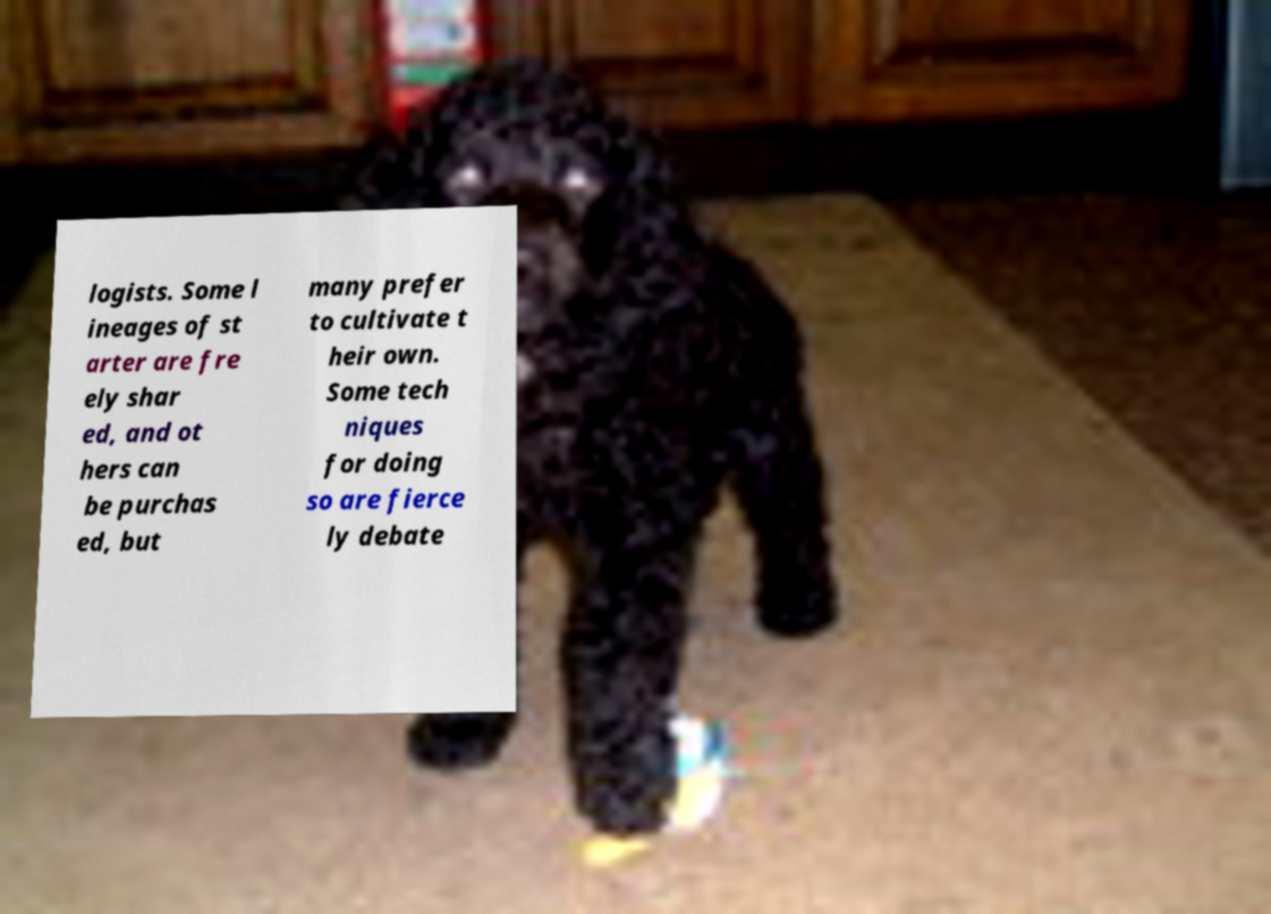Can you accurately transcribe the text from the provided image for me? logists. Some l ineages of st arter are fre ely shar ed, and ot hers can be purchas ed, but many prefer to cultivate t heir own. Some tech niques for doing so are fierce ly debate 